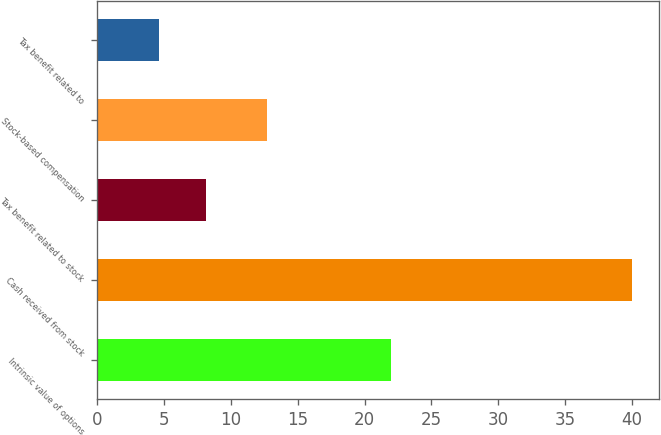<chart> <loc_0><loc_0><loc_500><loc_500><bar_chart><fcel>Intrinsic value of options<fcel>Cash received from stock<fcel>Tax benefit related to stock<fcel>Stock-based compensation<fcel>Tax benefit related to<nl><fcel>22<fcel>40<fcel>8.14<fcel>12.7<fcel>4.6<nl></chart> 